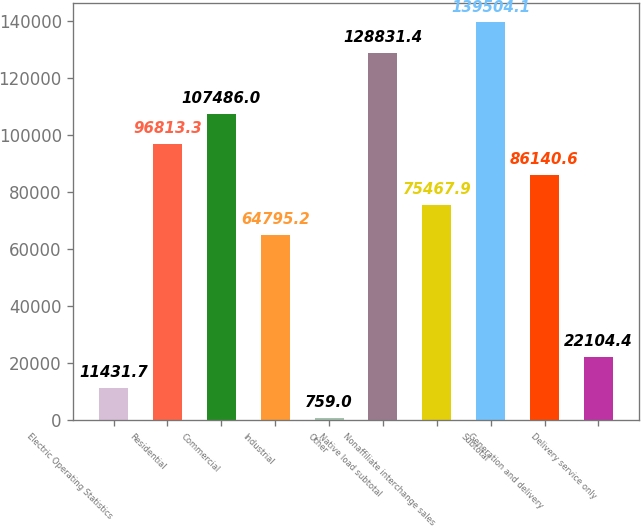Convert chart to OTSL. <chart><loc_0><loc_0><loc_500><loc_500><bar_chart><fcel>Electric Operating Statistics<fcel>Residential<fcel>Commercial<fcel>Industrial<fcel>Other<fcel>Native load subtotal<fcel>Nonaffiliate interchange sales<fcel>Subtotal<fcel>Generation and delivery<fcel>Delivery service only<nl><fcel>11431.7<fcel>96813.3<fcel>107486<fcel>64795.2<fcel>759<fcel>128831<fcel>75467.9<fcel>139504<fcel>86140.6<fcel>22104.4<nl></chart> 